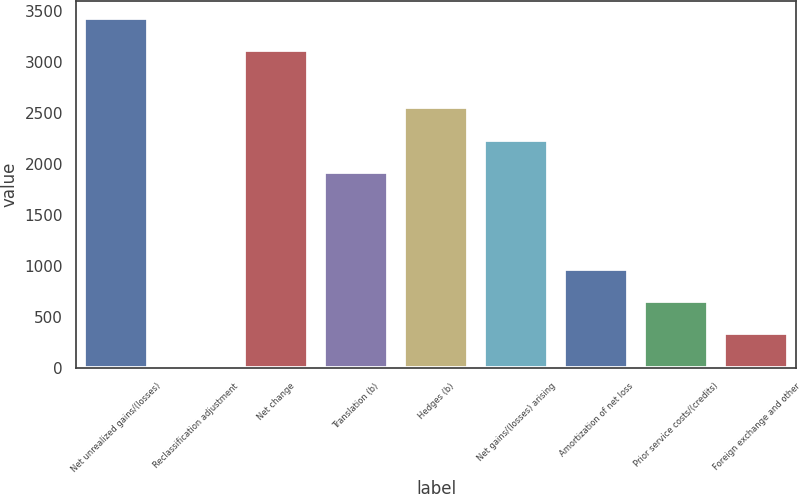Convert chart. <chart><loc_0><loc_0><loc_500><loc_500><bar_chart><fcel>Net unrealized gains/(losses)<fcel>Reclassification adjustment<fcel>Net change<fcel>Translation (b)<fcel>Hedges (b)<fcel>Net gains/(losses) arising<fcel>Amortization of net loss<fcel>Prior service costs/(credits)<fcel>Foreign exchange and other<nl><fcel>3432.9<fcel>24<fcel>3116<fcel>1925.4<fcel>2559.2<fcel>2242.3<fcel>974.7<fcel>657.8<fcel>340.9<nl></chart> 